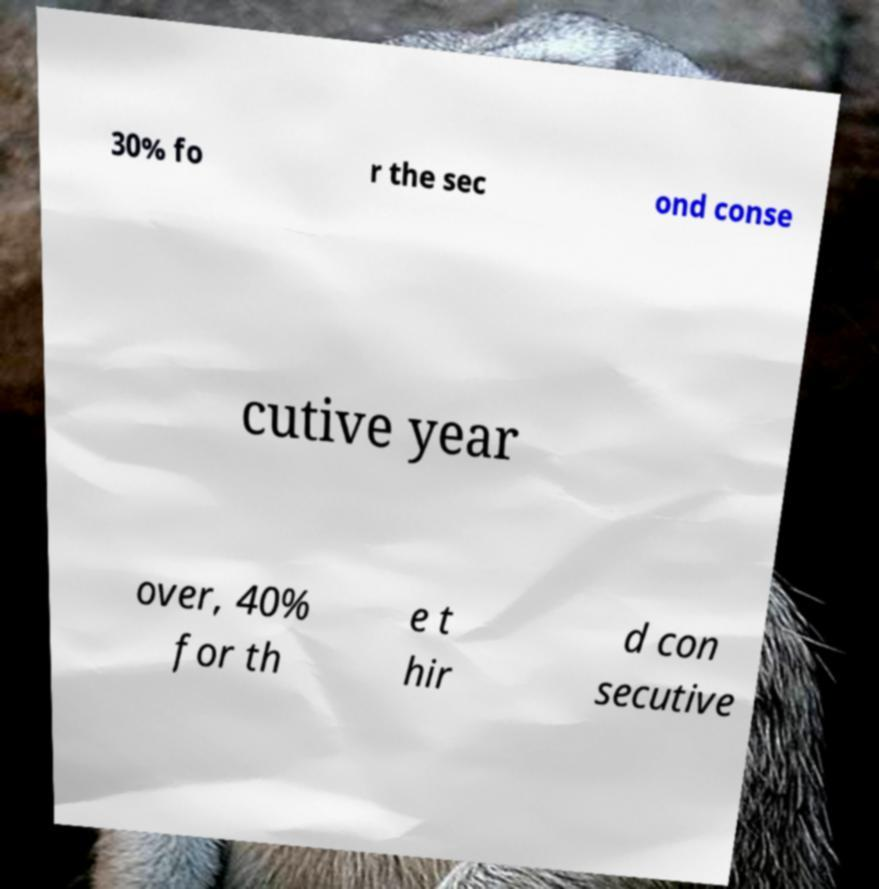I need the written content from this picture converted into text. Can you do that? 30% fo r the sec ond conse cutive year over, 40% for th e t hir d con secutive 